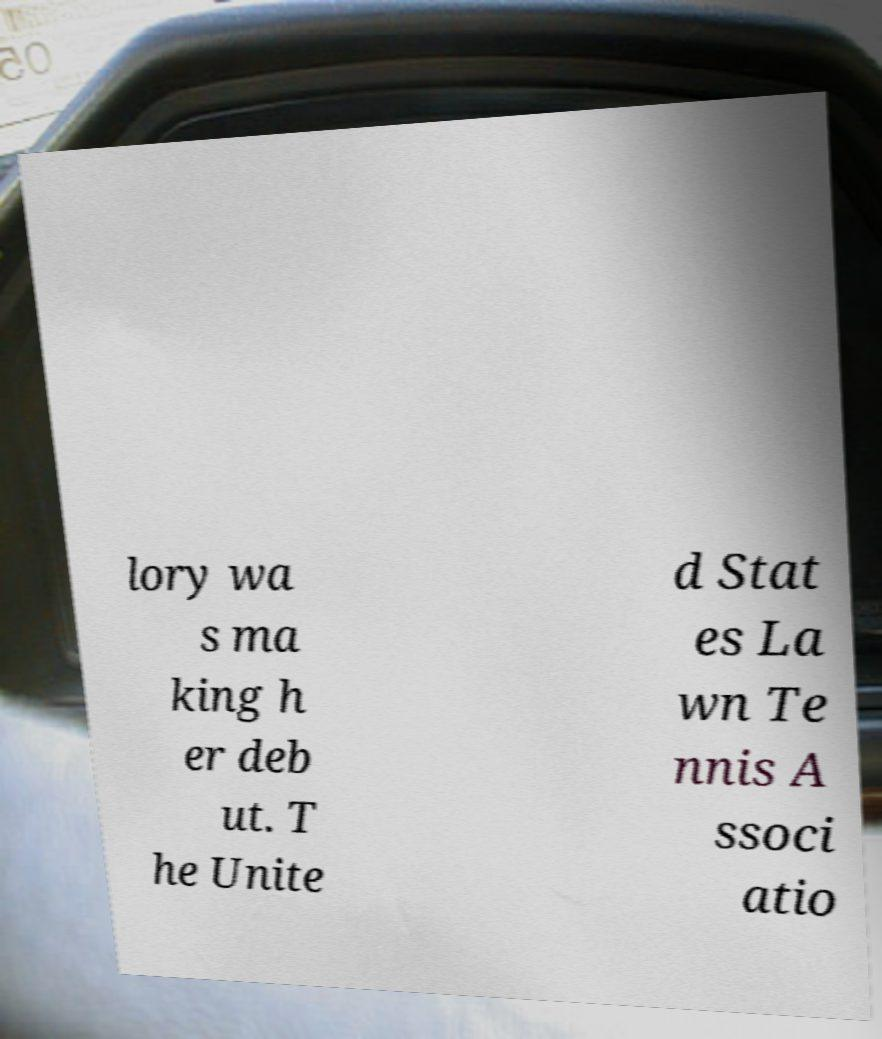Could you assist in decoding the text presented in this image and type it out clearly? lory wa s ma king h er deb ut. T he Unite d Stat es La wn Te nnis A ssoci atio 